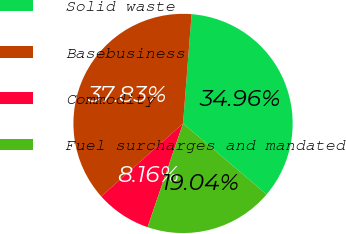Convert chart. <chart><loc_0><loc_0><loc_500><loc_500><pie_chart><fcel>Solid waste<fcel>Basebusiness<fcel>Commodity<fcel>Fuel surcharges and mandated<nl><fcel>34.96%<fcel>37.83%<fcel>8.16%<fcel>19.04%<nl></chart> 